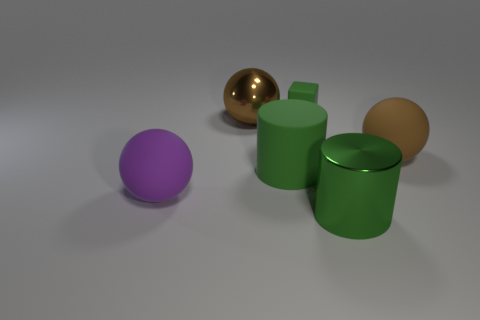Add 3 big blue things. How many objects exist? 9 Subtract all blocks. How many objects are left? 5 Add 4 shiny objects. How many shiny objects are left? 6 Add 3 large green shiny cylinders. How many large green shiny cylinders exist? 4 Subtract 0 purple cylinders. How many objects are left? 6 Subtract all tiny green objects. Subtract all brown rubber spheres. How many objects are left? 4 